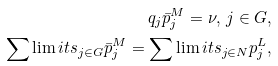<formula> <loc_0><loc_0><loc_500><loc_500>q _ { j } \bar { p } ^ { M } _ { j } = \nu , \, j \in G , \\ \sum \lim i t s _ { j \in G } \bar { p } _ { j } ^ { M } = \sum \lim i t s _ { j \in N } p _ { j } ^ { L } ,</formula> 